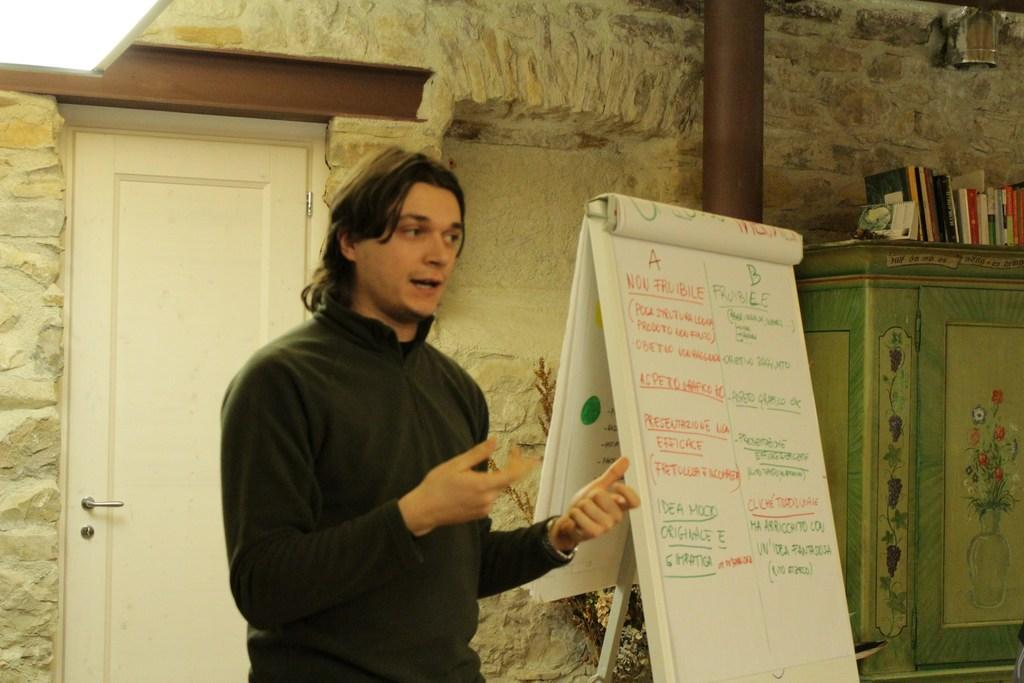Who or what is the main subject in the image? There is a person in the image. What object is visible in the image besides the person? There is a board in the image. What can be seen in the background of the room? In the background of the image, there is a cupboard with books on it, a wall, a pillar, and a door. Can you describe the setting of the image? The image is taken in a room. What type of flower is being used as a reason for the person's actions in the image? There is no flower or reason mentioned in the image; it only shows a person and a board. What kind of haircut does the person have in the image? The image does not show the person's haircut, as it focuses on the person and the board. 